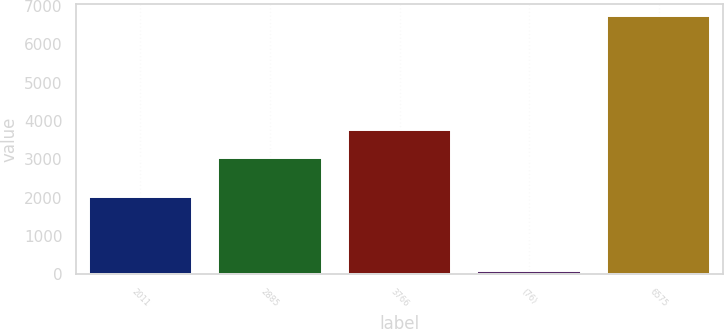<chart> <loc_0><loc_0><loc_500><loc_500><bar_chart><fcel>2011<fcel>2885<fcel>3766<fcel>(76)<fcel>6575<nl><fcel>2010<fcel>3027<fcel>3775<fcel>79<fcel>6723<nl></chart> 